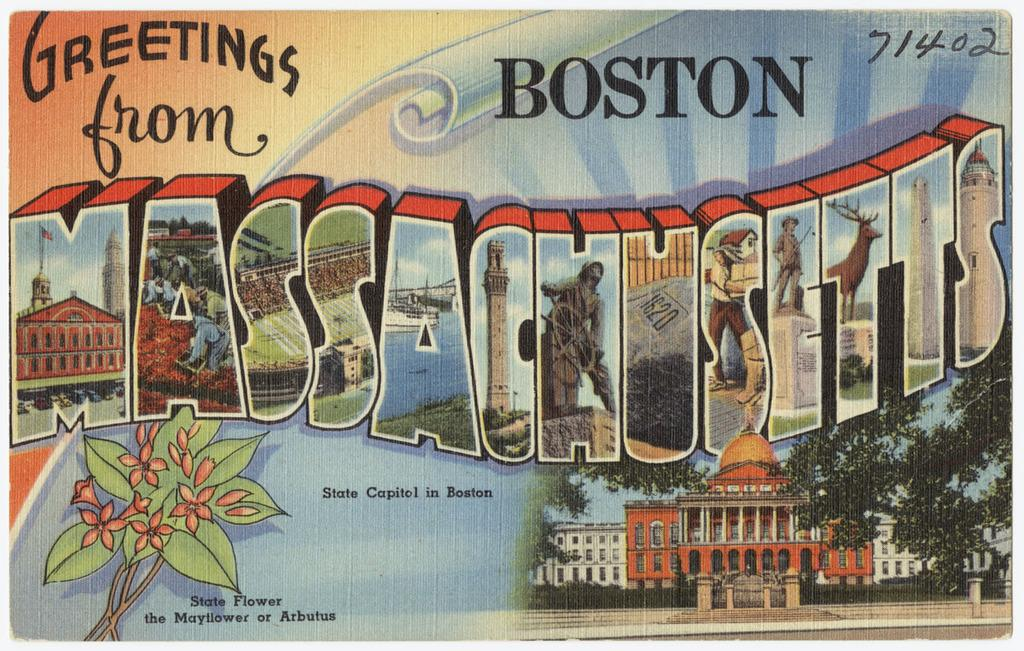<image>
Create a compact narrative representing the image presented. The greetings card is clearly from the state of Boston 